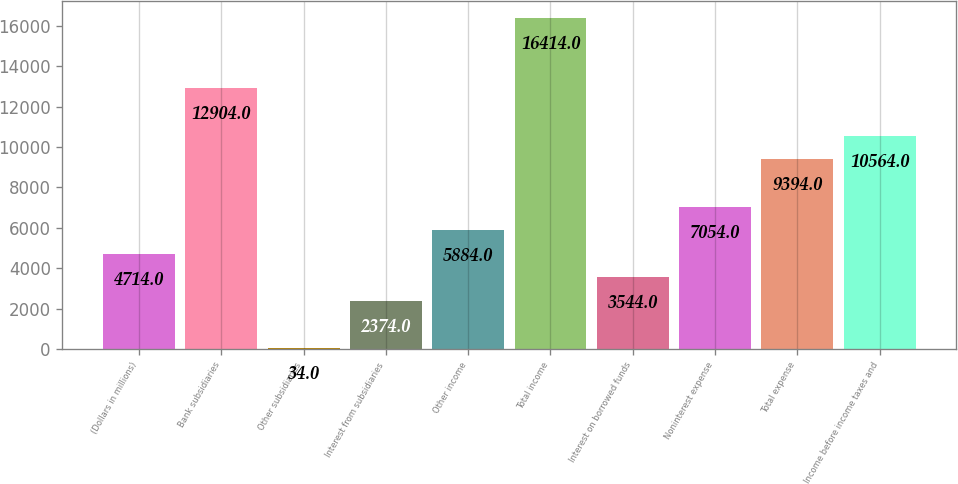<chart> <loc_0><loc_0><loc_500><loc_500><bar_chart><fcel>(Dollars in millions)<fcel>Bank subsidiaries<fcel>Other subsidiaries<fcel>Interest from subsidiaries<fcel>Other income<fcel>Total income<fcel>Interest on borrowed funds<fcel>Noninterest expense<fcel>Total expense<fcel>Income before income taxes and<nl><fcel>4714<fcel>12904<fcel>34<fcel>2374<fcel>5884<fcel>16414<fcel>3544<fcel>7054<fcel>9394<fcel>10564<nl></chart> 